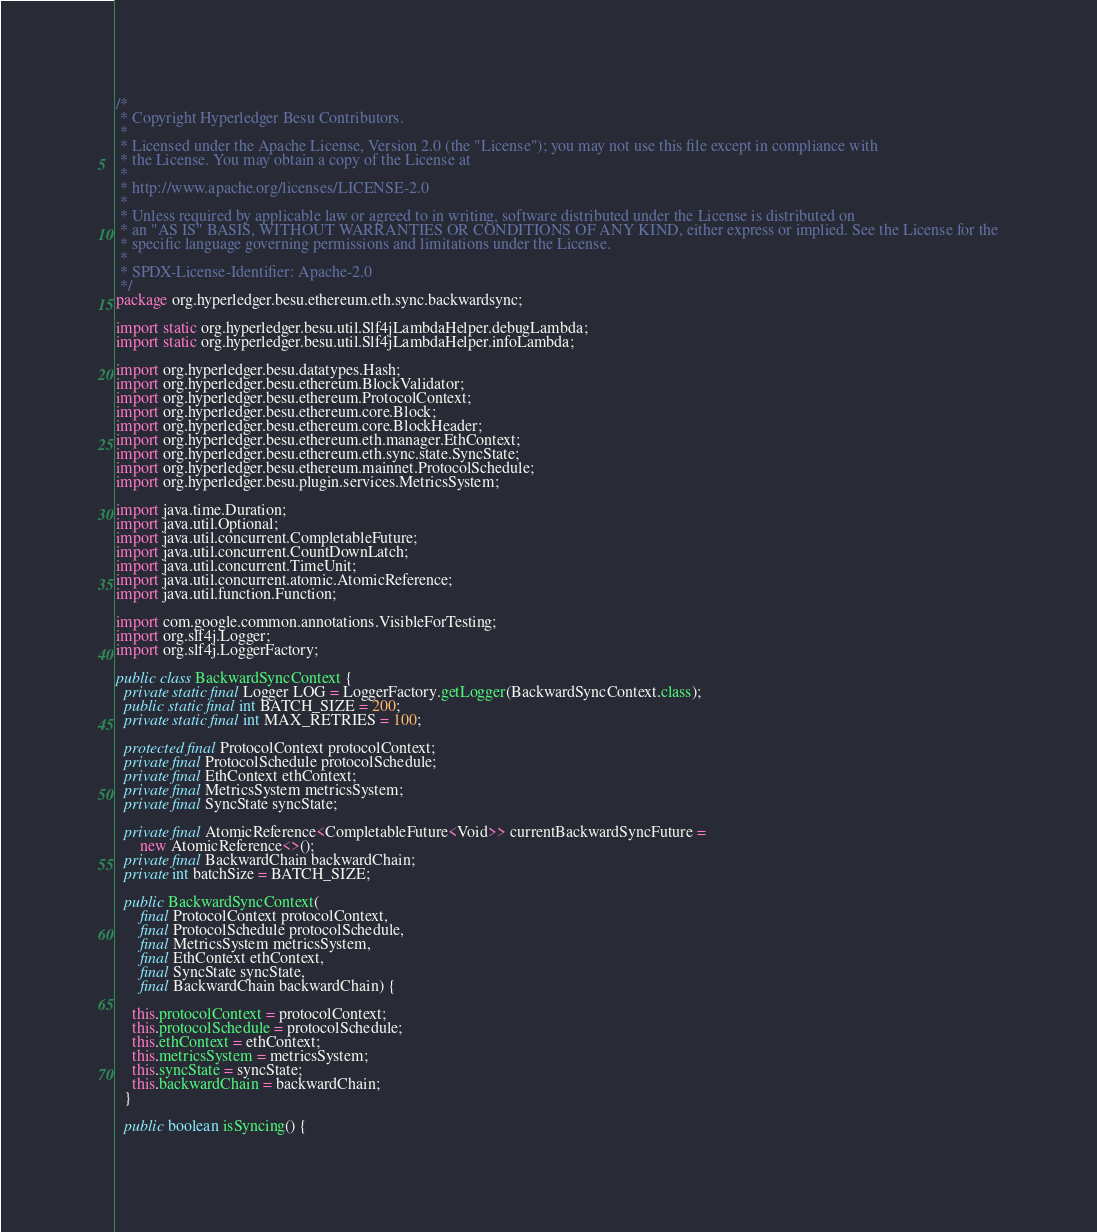<code> <loc_0><loc_0><loc_500><loc_500><_Java_>/*
 * Copyright Hyperledger Besu Contributors.
 *
 * Licensed under the Apache License, Version 2.0 (the "License"); you may not use this file except in compliance with
 * the License. You may obtain a copy of the License at
 *
 * http://www.apache.org/licenses/LICENSE-2.0
 *
 * Unless required by applicable law or agreed to in writing, software distributed under the License is distributed on
 * an "AS IS" BASIS, WITHOUT WARRANTIES OR CONDITIONS OF ANY KIND, either express or implied. See the License for the
 * specific language governing permissions and limitations under the License.
 *
 * SPDX-License-Identifier: Apache-2.0
 */
package org.hyperledger.besu.ethereum.eth.sync.backwardsync;

import static org.hyperledger.besu.util.Slf4jLambdaHelper.debugLambda;
import static org.hyperledger.besu.util.Slf4jLambdaHelper.infoLambda;

import org.hyperledger.besu.datatypes.Hash;
import org.hyperledger.besu.ethereum.BlockValidator;
import org.hyperledger.besu.ethereum.ProtocolContext;
import org.hyperledger.besu.ethereum.core.Block;
import org.hyperledger.besu.ethereum.core.BlockHeader;
import org.hyperledger.besu.ethereum.eth.manager.EthContext;
import org.hyperledger.besu.ethereum.eth.sync.state.SyncState;
import org.hyperledger.besu.ethereum.mainnet.ProtocolSchedule;
import org.hyperledger.besu.plugin.services.MetricsSystem;

import java.time.Duration;
import java.util.Optional;
import java.util.concurrent.CompletableFuture;
import java.util.concurrent.CountDownLatch;
import java.util.concurrent.TimeUnit;
import java.util.concurrent.atomic.AtomicReference;
import java.util.function.Function;

import com.google.common.annotations.VisibleForTesting;
import org.slf4j.Logger;
import org.slf4j.LoggerFactory;

public class BackwardSyncContext {
  private static final Logger LOG = LoggerFactory.getLogger(BackwardSyncContext.class);
  public static final int BATCH_SIZE = 200;
  private static final int MAX_RETRIES = 100;

  protected final ProtocolContext protocolContext;
  private final ProtocolSchedule protocolSchedule;
  private final EthContext ethContext;
  private final MetricsSystem metricsSystem;
  private final SyncState syncState;

  private final AtomicReference<CompletableFuture<Void>> currentBackwardSyncFuture =
      new AtomicReference<>();
  private final BackwardChain backwardChain;
  private int batchSize = BATCH_SIZE;

  public BackwardSyncContext(
      final ProtocolContext protocolContext,
      final ProtocolSchedule protocolSchedule,
      final MetricsSystem metricsSystem,
      final EthContext ethContext,
      final SyncState syncState,
      final BackwardChain backwardChain) {

    this.protocolContext = protocolContext;
    this.protocolSchedule = protocolSchedule;
    this.ethContext = ethContext;
    this.metricsSystem = metricsSystem;
    this.syncState = syncState;
    this.backwardChain = backwardChain;
  }

  public boolean isSyncing() {</code> 